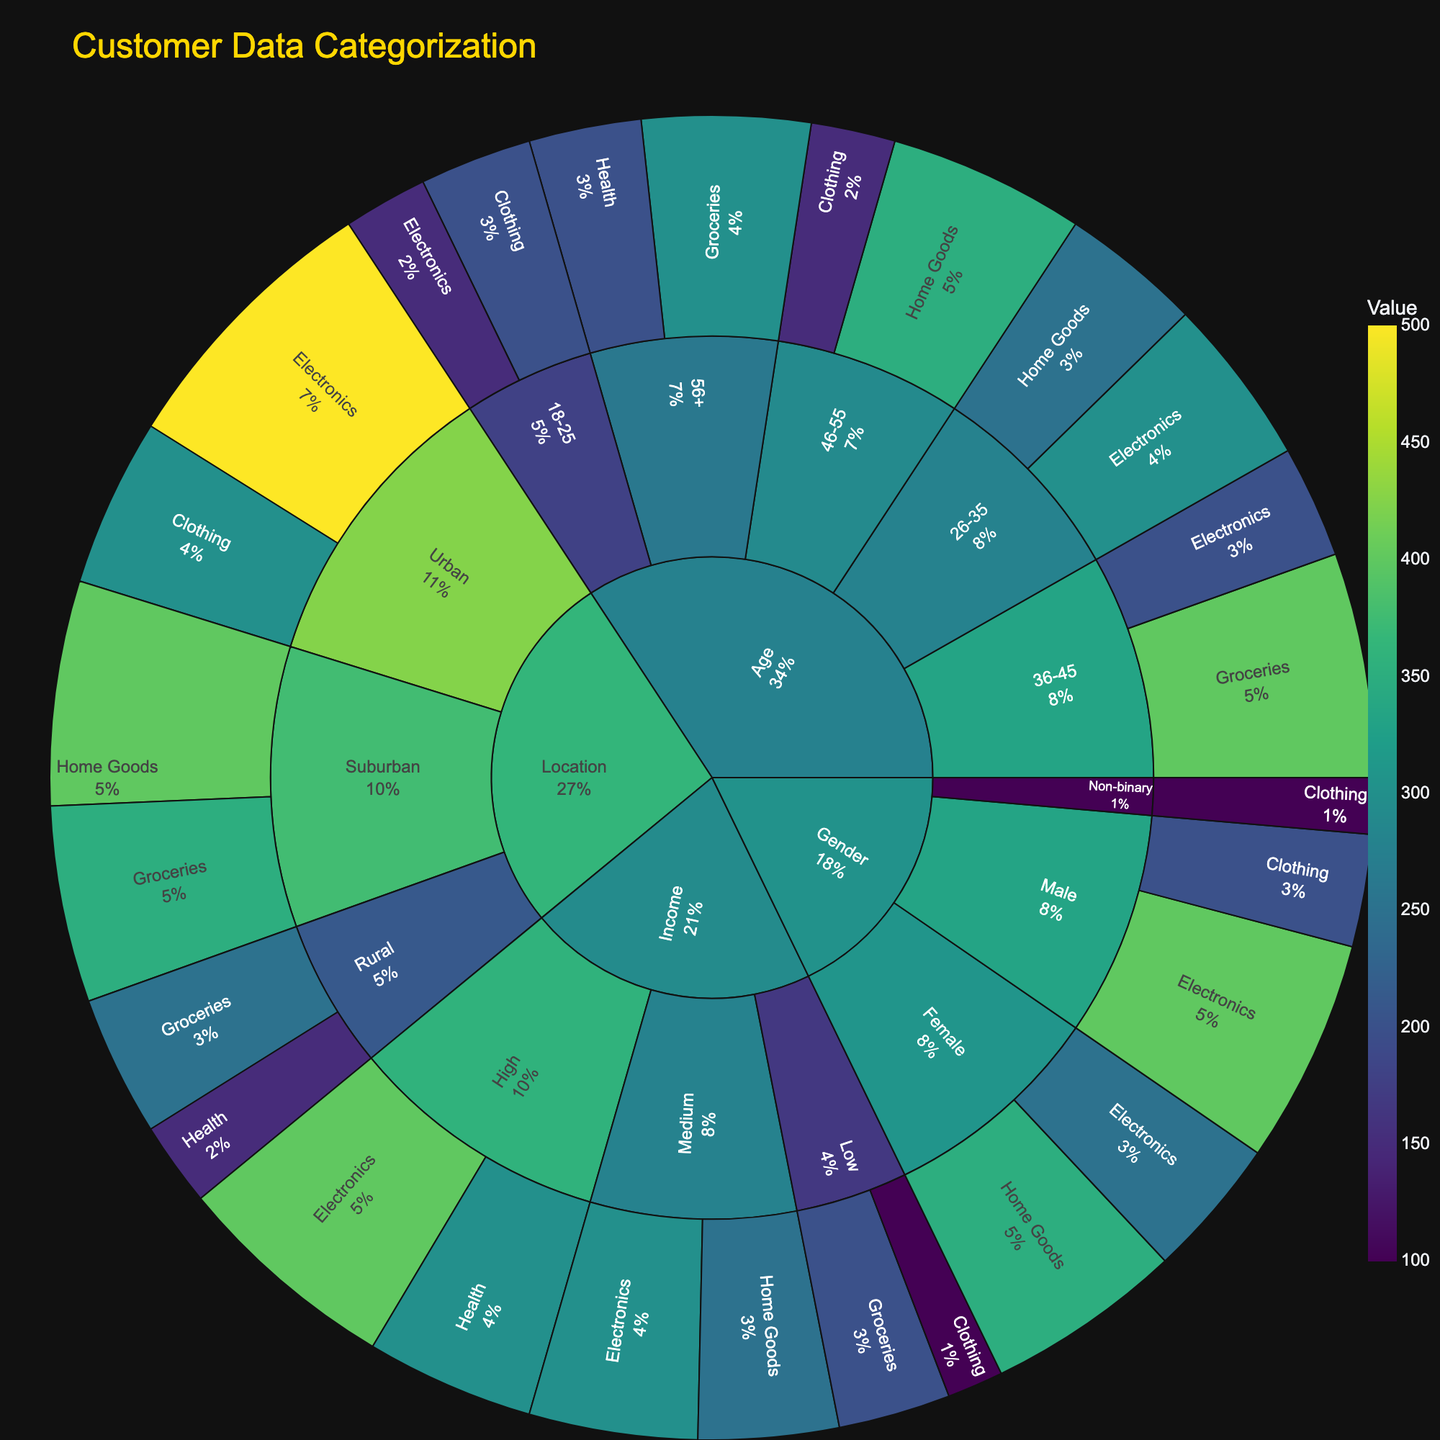what is the title of the figure? The title is typically located at the top-center of the plot. In this figure, it's clearly labeled "Customer Data Categorization".
Answer: Customer Data Categorization What is the highest purchasing category for the 26-35 age group? Look at the section corresponding to the 26-35 age group, then find the subcategory with the largest value. Electronics has 300 which is higher than Home Goods at 250.
Answer: Electronics Which gender has the highest total spending? Identify total spending for each gender by summing the values for each subcategory: 
- Male (400 + 200) = 600
- Female (250 + 350) = 600
- Non-binary = 100
Both Male and Female have equal spending at 600
Answer: Male and Female How do Urban electronics purchases compare to Rural grocery purchases? Locate Urban and Rural nodes; find the respective subcategories. Urban-Electronics is 500, and Rural-Groceries is 250. Urban Electronics purchases are double the Rural groceries purchases.
Answer: Urban Electronics are double What category has the highest value in the Low income group? Navigate to the Income category, then to Low, and see the highest value among Groceries and Clothing. Groceries leading with 200 over Clothing's 100.
Answer: Groceries What is the difference in spending on Home Goods between Suburban and Urban areas? Suburban Home Goods is 400, while Urban Home Goods is not listed. Suburban has a total of 400 more than Urban for that subcategory as Urban has none.
Answer: 400 Which age group spends the most on Health? Look at Health subcategory values among different age groups: 56+ age group spends 200 and others don't have Health spending values.
Answer: 56+ Compare the value of Electronics between High income and Medium income groups. Which is higher? High income is 400, Medium income is 300. High income group has 100 more in Electronics spending than Medium group.
Answer: High Which location has the least spending on Health, and what is its value? Check Health spending values in different locations: 
- Rural, 150 
- Urban and Suburban have no values. 
Thus, Rural is the only one and has Health spending of 150.
Answer: Rural, 150 